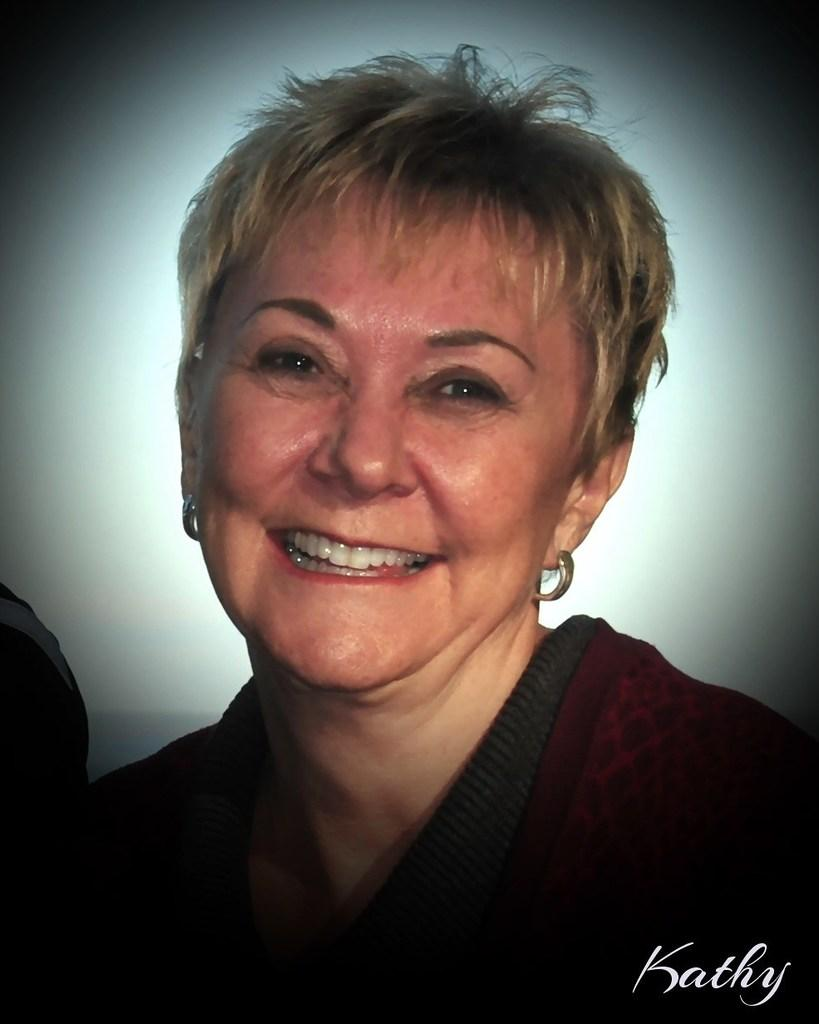Who is present in the image? There is a woman in the image. What is the woman's expression? The woman is smiling. Can you describe any additional features of the image? There is a watermark in the image, and it appears to be slightly dark. What role does the actor play in the show depicted in the image? There is no actor or show present in the image; it features a woman smiling. 